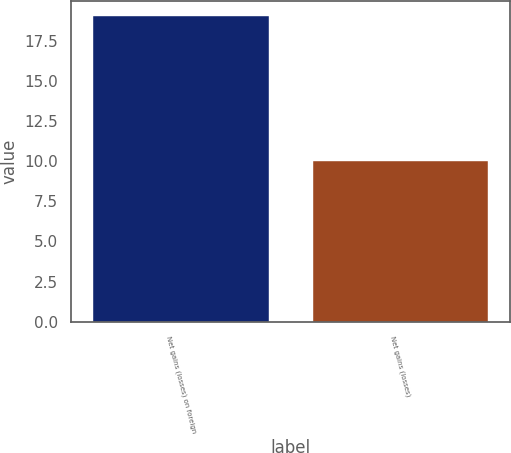Convert chart. <chart><loc_0><loc_0><loc_500><loc_500><bar_chart><fcel>Net gains (losses) on foreign<fcel>Net gains (losses)<nl><fcel>19<fcel>10<nl></chart> 